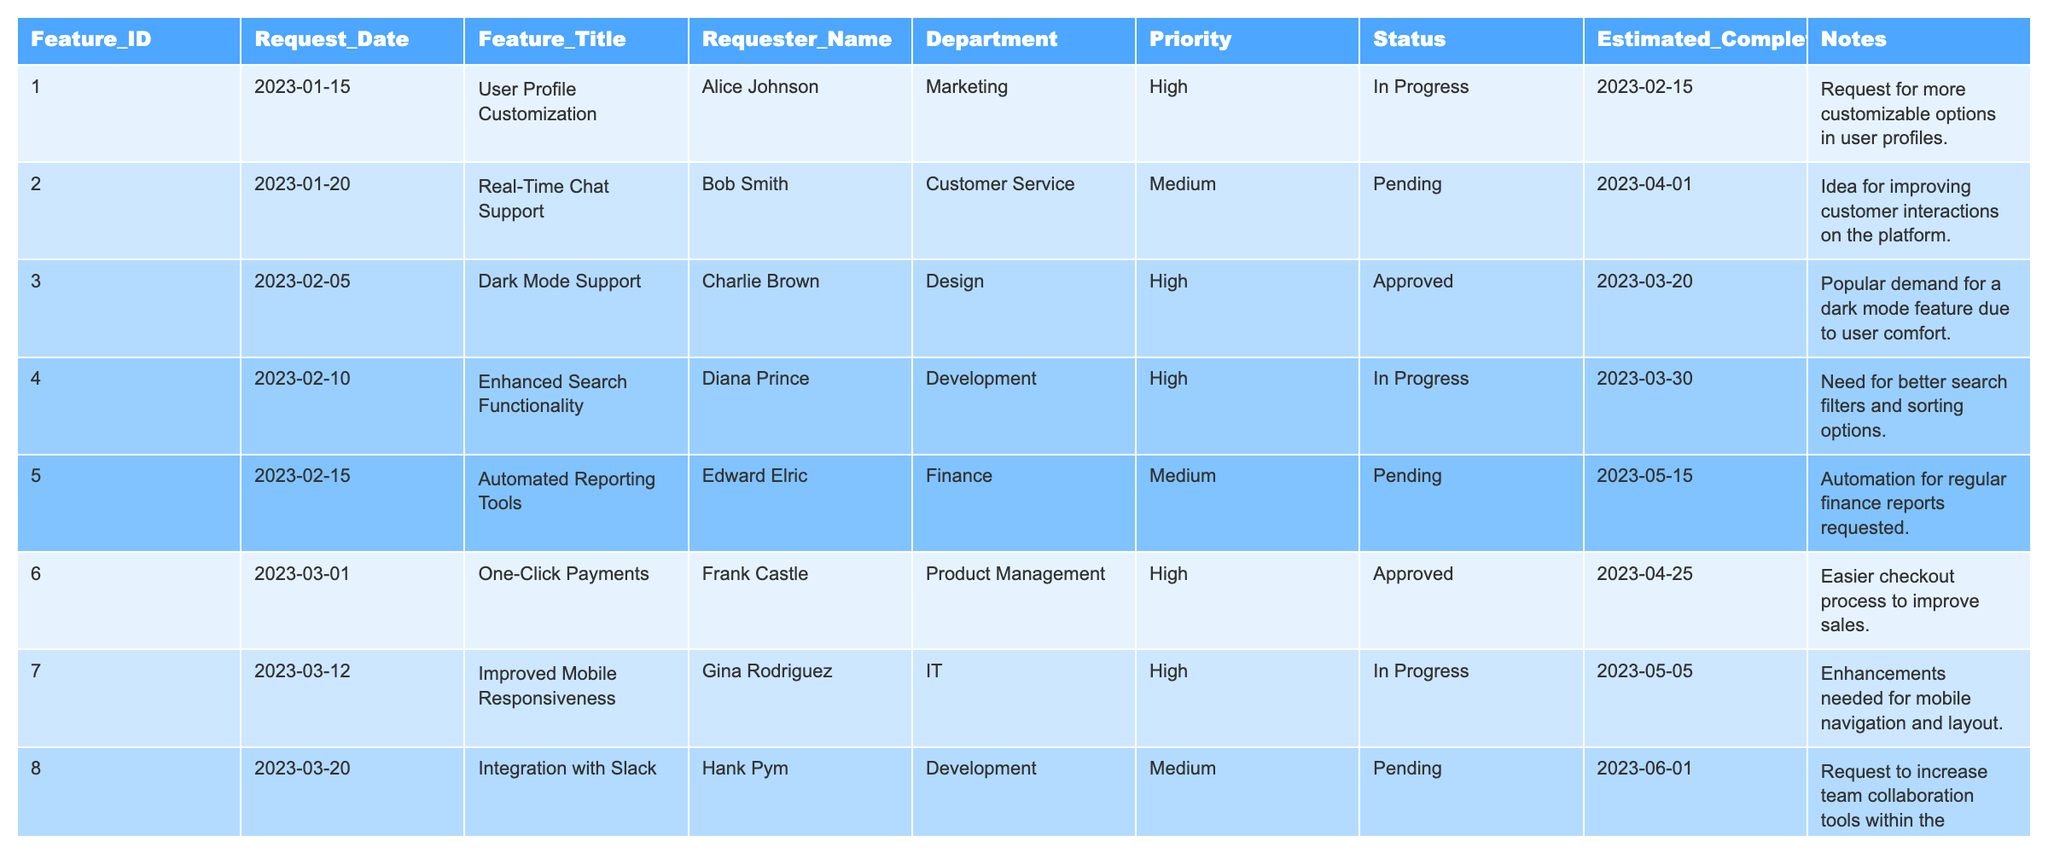What is the title of the feature that has the highest priority from the "Finance" department? The table shows that there are two features from the "Finance" department: "Automated Reporting Tools" (Medium priority) and "Data Export Options" (Medium priority). Since both have the same priority, the answer is the first one listed, "Automated Reporting Tools."
Answer: Automated Reporting Tools How many features have a status of "Pending"? Counting the rows in the table, there are five features with "Pending" status.
Answer: 5 Which feature's completion date is the latest? Looking through the "Estimated Completion Date" column, "Multi-Language Support" has the latest date of 2023-07-20.
Answer: Multi-Language Support Is there any feature in the "Marketing" department with a status of "Approved"? The "Marketing" department has two features: "User Profile Customization" (In Progress) and "Customizable Notification Settings" (In Progress). Both are not "Approved."
Answer: No What percentage of features are 'In Progress' compared to the total number of features? There are 15 features in total, and 6 of those are 'In Progress.' The percentage is calculated as (6/15) * 100 = 40%.
Answer: 40% Which feature has the earliest request date and what is its title? The feature with the earliest request date is "User Profile Customization," requested on 2023-01-15.
Answer: User Profile Customization How many features have "High" priority and what percentage do they represent? There are 7 features with a "High" priority. To find the percentage, (7/15) * 100 = 46.67%, which is approximately 47%.
Answer: 47% What is the average estimated completion date of features with a "Medium" priority? The features with "Medium" priority have estimated completion dates of 2023-04-01, 2023-05-15, 2023-06-01, 2023-07-20, and 2023-08-15. The average date comes from summing these dates and dividing by the number of "Medium" priority features, which yields an average estimated completion date of approximately 2023-06-03.
Answer: 2023-06-03 Name the departments that have features with the status "Approved." The table contains features with "Approved" status from the "Design," "Product Management," and "Finance" departments.
Answer: Design, Product Management, Finance Which feature has been requested by the most recent date and what is its title? The most recent request date recorded in the table is 2023-07-01 for the feature "Image Upload Enhancements."
Answer: Image Upload Enhancements 